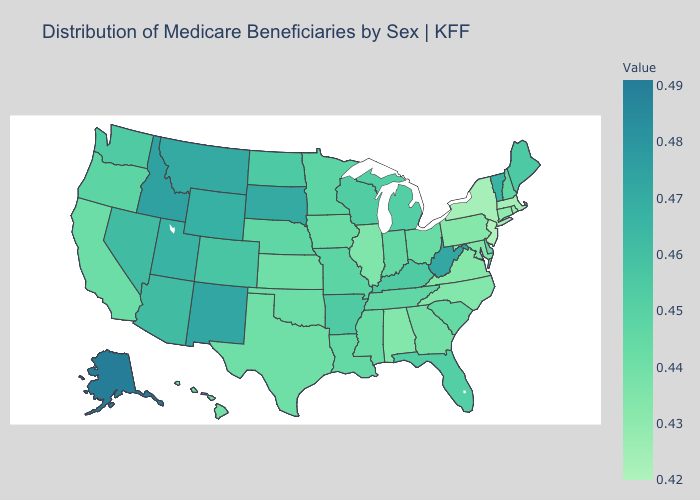Does the map have missing data?
Answer briefly. No. Among the states that border Delaware , does Pennsylvania have the lowest value?
Short answer required. No. Among the states that border Iowa , does Illinois have the lowest value?
Answer briefly. Yes. Among the states that border Ohio , does Michigan have the highest value?
Answer briefly. No. Which states have the lowest value in the Northeast?
Short answer required. New Jersey. Among the states that border Louisiana , does Texas have the highest value?
Be succinct. No. Among the states that border New Hampshire , which have the lowest value?
Give a very brief answer. Massachusetts. 